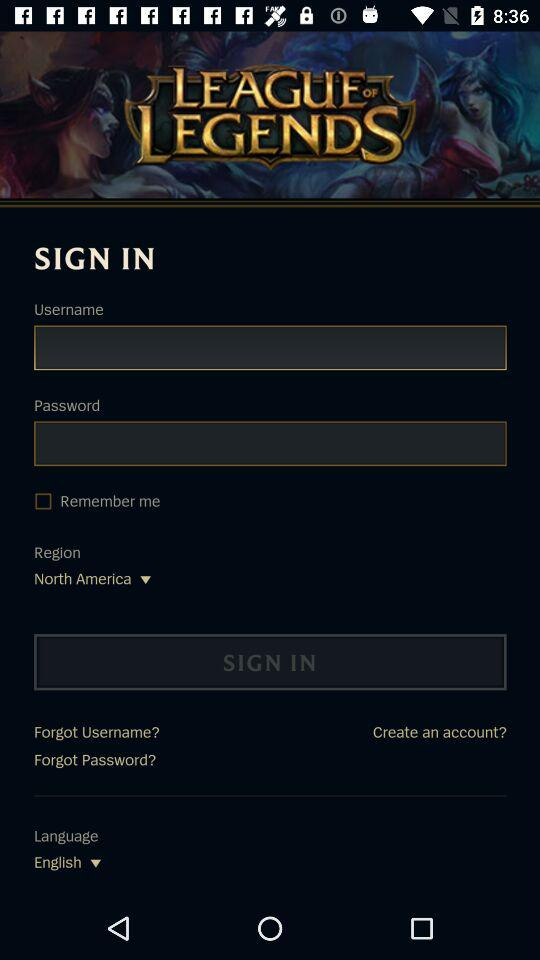What is the app name? The app is "LEAGUE OF LEGENDS". 